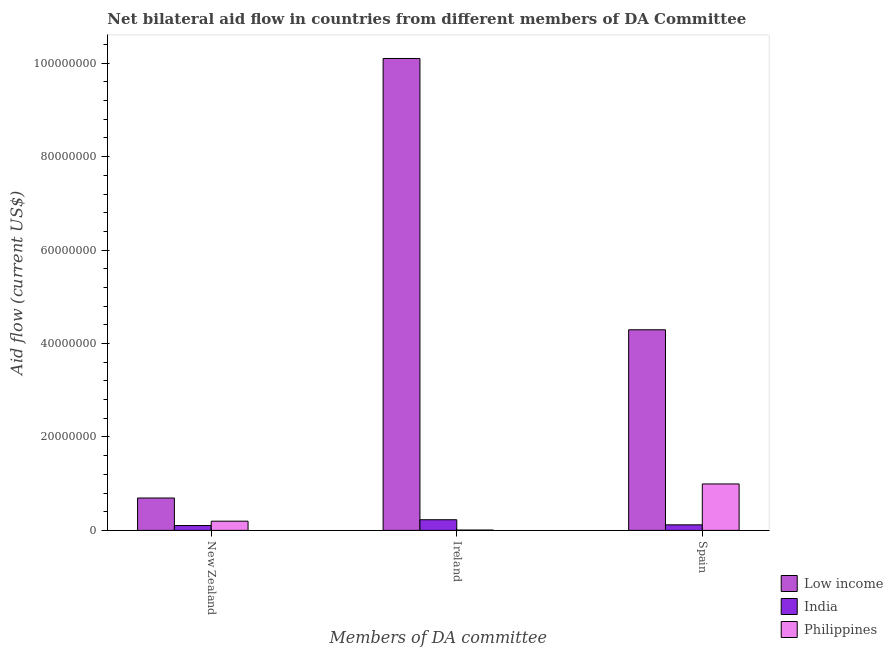How many different coloured bars are there?
Ensure brevity in your answer.  3. Are the number of bars per tick equal to the number of legend labels?
Provide a short and direct response. Yes. How many bars are there on the 1st tick from the right?
Offer a terse response. 3. What is the amount of aid provided by ireland in Philippines?
Your response must be concise. 7.00e+04. Across all countries, what is the maximum amount of aid provided by spain?
Make the answer very short. 4.29e+07. Across all countries, what is the minimum amount of aid provided by new zealand?
Give a very brief answer. 1.04e+06. In which country was the amount of aid provided by new zealand minimum?
Your answer should be compact. India. What is the total amount of aid provided by ireland in the graph?
Your answer should be compact. 1.03e+08. What is the difference between the amount of aid provided by ireland in India and that in Philippines?
Your answer should be very brief. 2.21e+06. What is the difference between the amount of aid provided by ireland in Low income and the amount of aid provided by spain in India?
Give a very brief answer. 9.98e+07. What is the average amount of aid provided by spain per country?
Offer a terse response. 1.80e+07. What is the difference between the amount of aid provided by new zealand and amount of aid provided by spain in Low income?
Provide a short and direct response. -3.60e+07. What is the ratio of the amount of aid provided by ireland in India to that in Low income?
Ensure brevity in your answer.  0.02. Is the amount of aid provided by spain in Low income less than that in India?
Provide a succinct answer. No. What is the difference between the highest and the second highest amount of aid provided by spain?
Your answer should be compact. 3.30e+07. What is the difference between the highest and the lowest amount of aid provided by new zealand?
Provide a succinct answer. 5.89e+06. In how many countries, is the amount of aid provided by spain greater than the average amount of aid provided by spain taken over all countries?
Offer a terse response. 1. Is the sum of the amount of aid provided by new zealand in India and Philippines greater than the maximum amount of aid provided by ireland across all countries?
Offer a very short reply. No. Is it the case that in every country, the sum of the amount of aid provided by new zealand and amount of aid provided by ireland is greater than the amount of aid provided by spain?
Your response must be concise. No. What is the difference between two consecutive major ticks on the Y-axis?
Your answer should be compact. 2.00e+07. Where does the legend appear in the graph?
Provide a short and direct response. Bottom right. What is the title of the graph?
Provide a short and direct response. Net bilateral aid flow in countries from different members of DA Committee. Does "Greece" appear as one of the legend labels in the graph?
Offer a terse response. No. What is the label or title of the X-axis?
Your answer should be very brief. Members of DA committee. What is the label or title of the Y-axis?
Offer a terse response. Aid flow (current US$). What is the Aid flow (current US$) in Low income in New Zealand?
Offer a terse response. 6.93e+06. What is the Aid flow (current US$) of India in New Zealand?
Offer a terse response. 1.04e+06. What is the Aid flow (current US$) of Philippines in New Zealand?
Keep it short and to the point. 1.97e+06. What is the Aid flow (current US$) in Low income in Ireland?
Make the answer very short. 1.01e+08. What is the Aid flow (current US$) in India in Ireland?
Keep it short and to the point. 2.28e+06. What is the Aid flow (current US$) of Low income in Spain?
Provide a succinct answer. 4.29e+07. What is the Aid flow (current US$) of India in Spain?
Give a very brief answer. 1.19e+06. What is the Aid flow (current US$) of Philippines in Spain?
Ensure brevity in your answer.  9.94e+06. Across all Members of DA committee, what is the maximum Aid flow (current US$) of Low income?
Make the answer very short. 1.01e+08. Across all Members of DA committee, what is the maximum Aid flow (current US$) in India?
Your response must be concise. 2.28e+06. Across all Members of DA committee, what is the maximum Aid flow (current US$) in Philippines?
Provide a succinct answer. 9.94e+06. Across all Members of DA committee, what is the minimum Aid flow (current US$) in Low income?
Your answer should be very brief. 6.93e+06. Across all Members of DA committee, what is the minimum Aid flow (current US$) of India?
Provide a short and direct response. 1.04e+06. What is the total Aid flow (current US$) of Low income in the graph?
Ensure brevity in your answer.  1.51e+08. What is the total Aid flow (current US$) of India in the graph?
Provide a short and direct response. 4.51e+06. What is the total Aid flow (current US$) of Philippines in the graph?
Your answer should be compact. 1.20e+07. What is the difference between the Aid flow (current US$) of Low income in New Zealand and that in Ireland?
Make the answer very short. -9.41e+07. What is the difference between the Aid flow (current US$) of India in New Zealand and that in Ireland?
Your answer should be very brief. -1.24e+06. What is the difference between the Aid flow (current US$) in Philippines in New Zealand and that in Ireland?
Make the answer very short. 1.90e+06. What is the difference between the Aid flow (current US$) in Low income in New Zealand and that in Spain?
Ensure brevity in your answer.  -3.60e+07. What is the difference between the Aid flow (current US$) in India in New Zealand and that in Spain?
Offer a very short reply. -1.50e+05. What is the difference between the Aid flow (current US$) in Philippines in New Zealand and that in Spain?
Offer a very short reply. -7.97e+06. What is the difference between the Aid flow (current US$) in Low income in Ireland and that in Spain?
Your response must be concise. 5.81e+07. What is the difference between the Aid flow (current US$) of India in Ireland and that in Spain?
Make the answer very short. 1.09e+06. What is the difference between the Aid flow (current US$) in Philippines in Ireland and that in Spain?
Your response must be concise. -9.87e+06. What is the difference between the Aid flow (current US$) in Low income in New Zealand and the Aid flow (current US$) in India in Ireland?
Ensure brevity in your answer.  4.65e+06. What is the difference between the Aid flow (current US$) in Low income in New Zealand and the Aid flow (current US$) in Philippines in Ireland?
Provide a succinct answer. 6.86e+06. What is the difference between the Aid flow (current US$) in India in New Zealand and the Aid flow (current US$) in Philippines in Ireland?
Ensure brevity in your answer.  9.70e+05. What is the difference between the Aid flow (current US$) in Low income in New Zealand and the Aid flow (current US$) in India in Spain?
Offer a terse response. 5.74e+06. What is the difference between the Aid flow (current US$) of Low income in New Zealand and the Aid flow (current US$) of Philippines in Spain?
Your response must be concise. -3.01e+06. What is the difference between the Aid flow (current US$) of India in New Zealand and the Aid flow (current US$) of Philippines in Spain?
Offer a very short reply. -8.90e+06. What is the difference between the Aid flow (current US$) of Low income in Ireland and the Aid flow (current US$) of India in Spain?
Provide a short and direct response. 9.98e+07. What is the difference between the Aid flow (current US$) of Low income in Ireland and the Aid flow (current US$) of Philippines in Spain?
Your answer should be very brief. 9.11e+07. What is the difference between the Aid flow (current US$) in India in Ireland and the Aid flow (current US$) in Philippines in Spain?
Your answer should be very brief. -7.66e+06. What is the average Aid flow (current US$) of Low income per Members of DA committee?
Give a very brief answer. 5.03e+07. What is the average Aid flow (current US$) in India per Members of DA committee?
Offer a very short reply. 1.50e+06. What is the average Aid flow (current US$) in Philippines per Members of DA committee?
Your answer should be compact. 3.99e+06. What is the difference between the Aid flow (current US$) in Low income and Aid flow (current US$) in India in New Zealand?
Make the answer very short. 5.89e+06. What is the difference between the Aid flow (current US$) in Low income and Aid flow (current US$) in Philippines in New Zealand?
Your answer should be very brief. 4.96e+06. What is the difference between the Aid flow (current US$) in India and Aid flow (current US$) in Philippines in New Zealand?
Make the answer very short. -9.30e+05. What is the difference between the Aid flow (current US$) in Low income and Aid flow (current US$) in India in Ireland?
Provide a succinct answer. 9.87e+07. What is the difference between the Aid flow (current US$) in Low income and Aid flow (current US$) in Philippines in Ireland?
Provide a succinct answer. 1.01e+08. What is the difference between the Aid flow (current US$) in India and Aid flow (current US$) in Philippines in Ireland?
Offer a very short reply. 2.21e+06. What is the difference between the Aid flow (current US$) of Low income and Aid flow (current US$) of India in Spain?
Offer a terse response. 4.18e+07. What is the difference between the Aid flow (current US$) of Low income and Aid flow (current US$) of Philippines in Spain?
Your answer should be very brief. 3.30e+07. What is the difference between the Aid flow (current US$) of India and Aid flow (current US$) of Philippines in Spain?
Give a very brief answer. -8.75e+06. What is the ratio of the Aid flow (current US$) of Low income in New Zealand to that in Ireland?
Make the answer very short. 0.07. What is the ratio of the Aid flow (current US$) of India in New Zealand to that in Ireland?
Your response must be concise. 0.46. What is the ratio of the Aid flow (current US$) of Philippines in New Zealand to that in Ireland?
Provide a succinct answer. 28.14. What is the ratio of the Aid flow (current US$) in Low income in New Zealand to that in Spain?
Your response must be concise. 0.16. What is the ratio of the Aid flow (current US$) of India in New Zealand to that in Spain?
Your response must be concise. 0.87. What is the ratio of the Aid flow (current US$) in Philippines in New Zealand to that in Spain?
Offer a terse response. 0.2. What is the ratio of the Aid flow (current US$) in Low income in Ireland to that in Spain?
Keep it short and to the point. 2.35. What is the ratio of the Aid flow (current US$) in India in Ireland to that in Spain?
Your answer should be compact. 1.92. What is the ratio of the Aid flow (current US$) of Philippines in Ireland to that in Spain?
Provide a succinct answer. 0.01. What is the difference between the highest and the second highest Aid flow (current US$) of Low income?
Keep it short and to the point. 5.81e+07. What is the difference between the highest and the second highest Aid flow (current US$) in India?
Ensure brevity in your answer.  1.09e+06. What is the difference between the highest and the second highest Aid flow (current US$) in Philippines?
Make the answer very short. 7.97e+06. What is the difference between the highest and the lowest Aid flow (current US$) of Low income?
Your response must be concise. 9.41e+07. What is the difference between the highest and the lowest Aid flow (current US$) in India?
Make the answer very short. 1.24e+06. What is the difference between the highest and the lowest Aid flow (current US$) in Philippines?
Provide a short and direct response. 9.87e+06. 